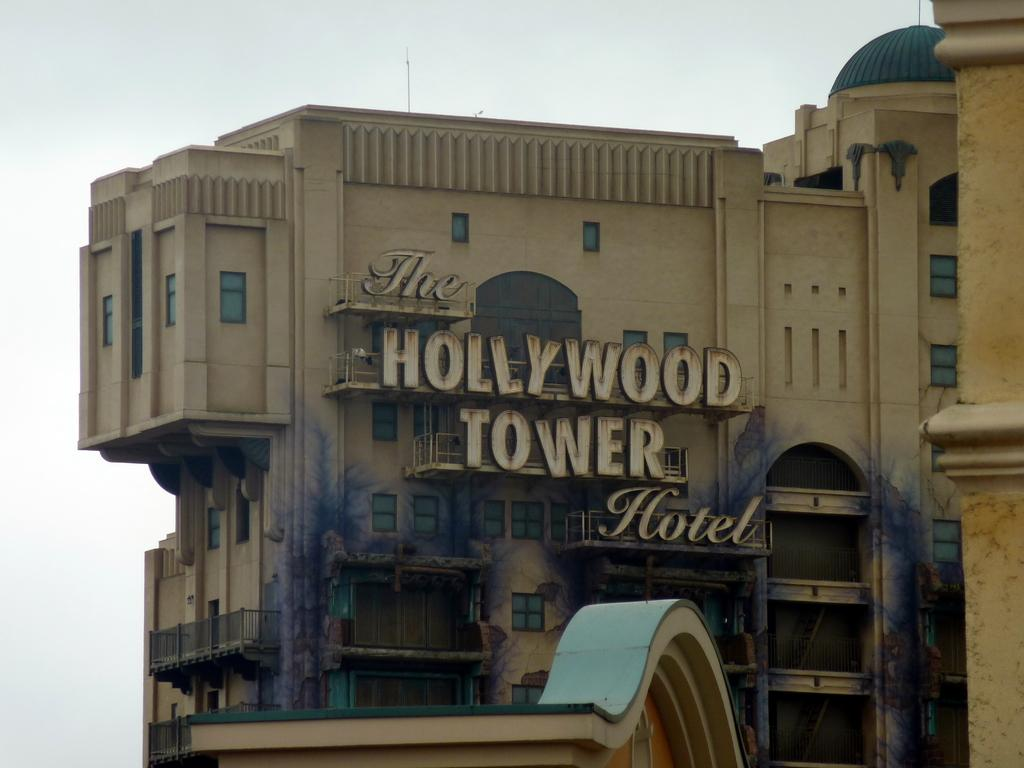Provide a one-sentence caption for the provided image. Here is a picture of the Hollywood Tower Hotel. 